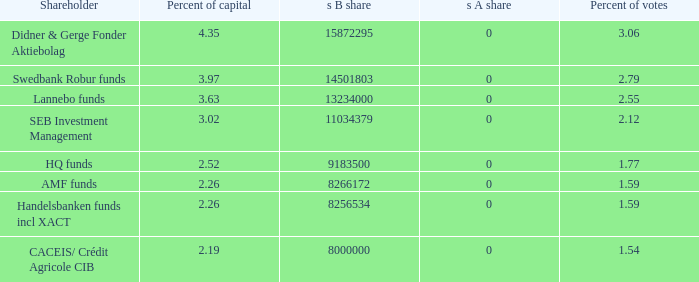What is the s B share for the shareholder that has 2.55 percent of votes?  13234000.0. 